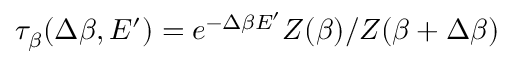Convert formula to latex. <formula><loc_0><loc_0><loc_500><loc_500>\tau _ { \beta } ( \Delta \beta , E ^ { \prime } ) = e ^ { - \Delta \beta E ^ { \prime } } Z ( \beta ) / Z ( \beta + \Delta \beta )</formula> 